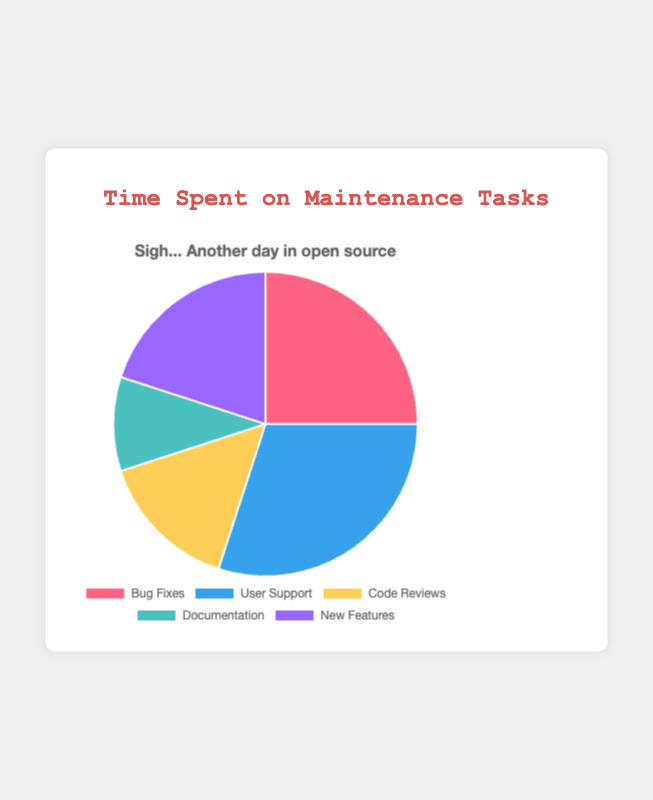What's the total percentage of time spent on User Support and Bug Fixes? The percentage of time spent on User Support is 30%, and on Bug Fixes is 25%. Adding these together: 30% + 25% = 55%.
Answer: 55% Which task has the least amount of time spent on it? By observing the data, Documentation has the lowest allocation with 10%.
Answer: Documentation How much more time is spent on User Support compared to Documentation? The time spent on User Support is 30% and on Documentation is 10%. The difference is: 30% - 10% = 20%.
Answer: 20% Is the percentage of time spent on New Features greater than that spent on Code Reviews? The data shows 20% is spent on New Features and 15% on Code Reviews. Since 20% > 15%, the answer is yes.
Answer: Yes What's the combined percentage of time spent on Code Reviews and New Features? Code Reviews take 15% and New Features take 20%. Adding these: 15% + 20% = 35%.
Answer: 35% Which task's time allocation is represented by the color blue? From the chart's dataset, User Support is represented by blue.
Answer: User Support Between Bug Fixes and New Features, which task has less time allocated? Bug Fixes have 25%, and New Features have 20%. Since 20% < 25%, New Features have less time allocated.
Answer: New Features How much more time is spent on Bug Fixes compared to Documentation? Bug Fixes have 25%, and Documentation has 10%. The difference is: 25% - 10% = 15%.
Answer: 15% What's the difference between the highest and the lowest time allocations? The highest percentage is User Support with 30%, and the lowest is Documentation with 10%. The difference is: 30% - 10% = 20%.
Answer: 20% What percentage of time is spent on tasks that involve direct code manipulation (Bug Fixes, Code Reviews, New Features)? Bug Fixes: 25%, Code Reviews: 15%, New Features: 20%. Adding these: 25% + 15% + 20% = 60%.
Answer: 60% 